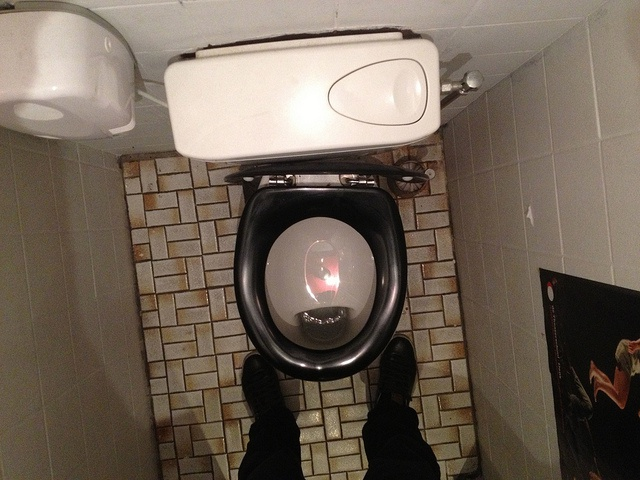Describe the objects in this image and their specific colors. I can see toilet in olive, lightgray, black, darkgray, and gray tones and people in olive, black, and gray tones in this image. 